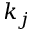<formula> <loc_0><loc_0><loc_500><loc_500>k _ { j }</formula> 